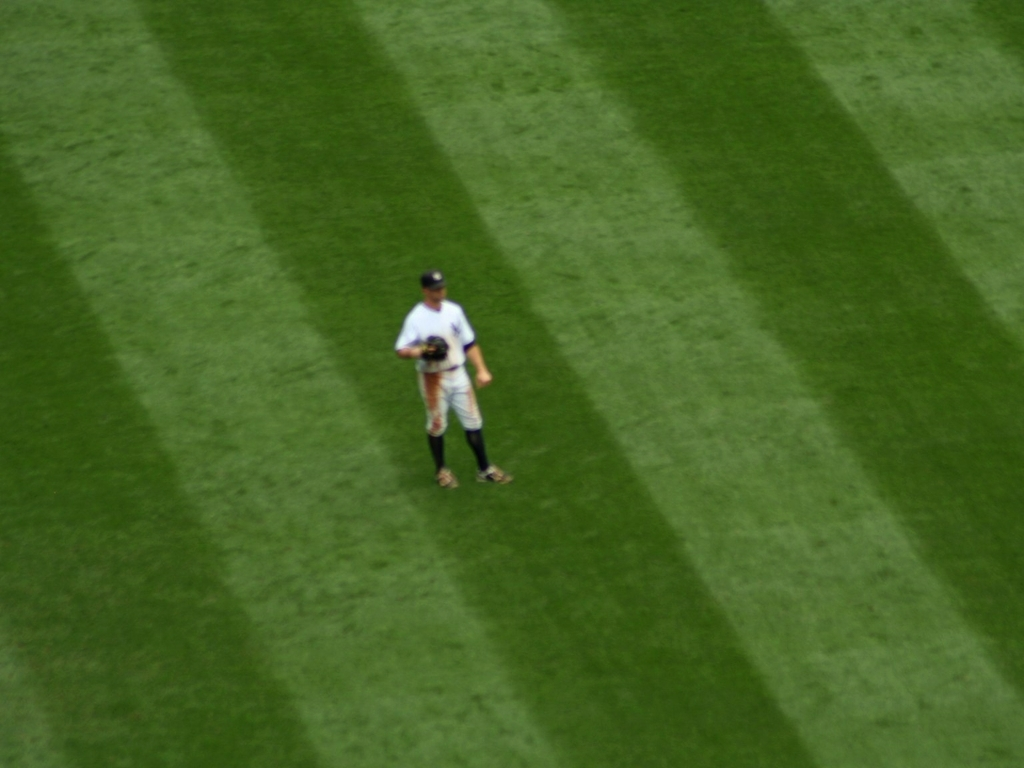How might the position of the sun contribute to the visibility of the stripes? The position of the sun can significantly affect how visible the stripes are. When the sun is lower in the sky, shadows are more pronounced, making the stripes more evident. Additionally, the angle of the sunlight can enhance the contrast between the bent and upright grass, increasing the visibility of the striping pattern. 